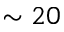Convert formula to latex. <formula><loc_0><loc_0><loc_500><loc_500>\sim 2 0</formula> 